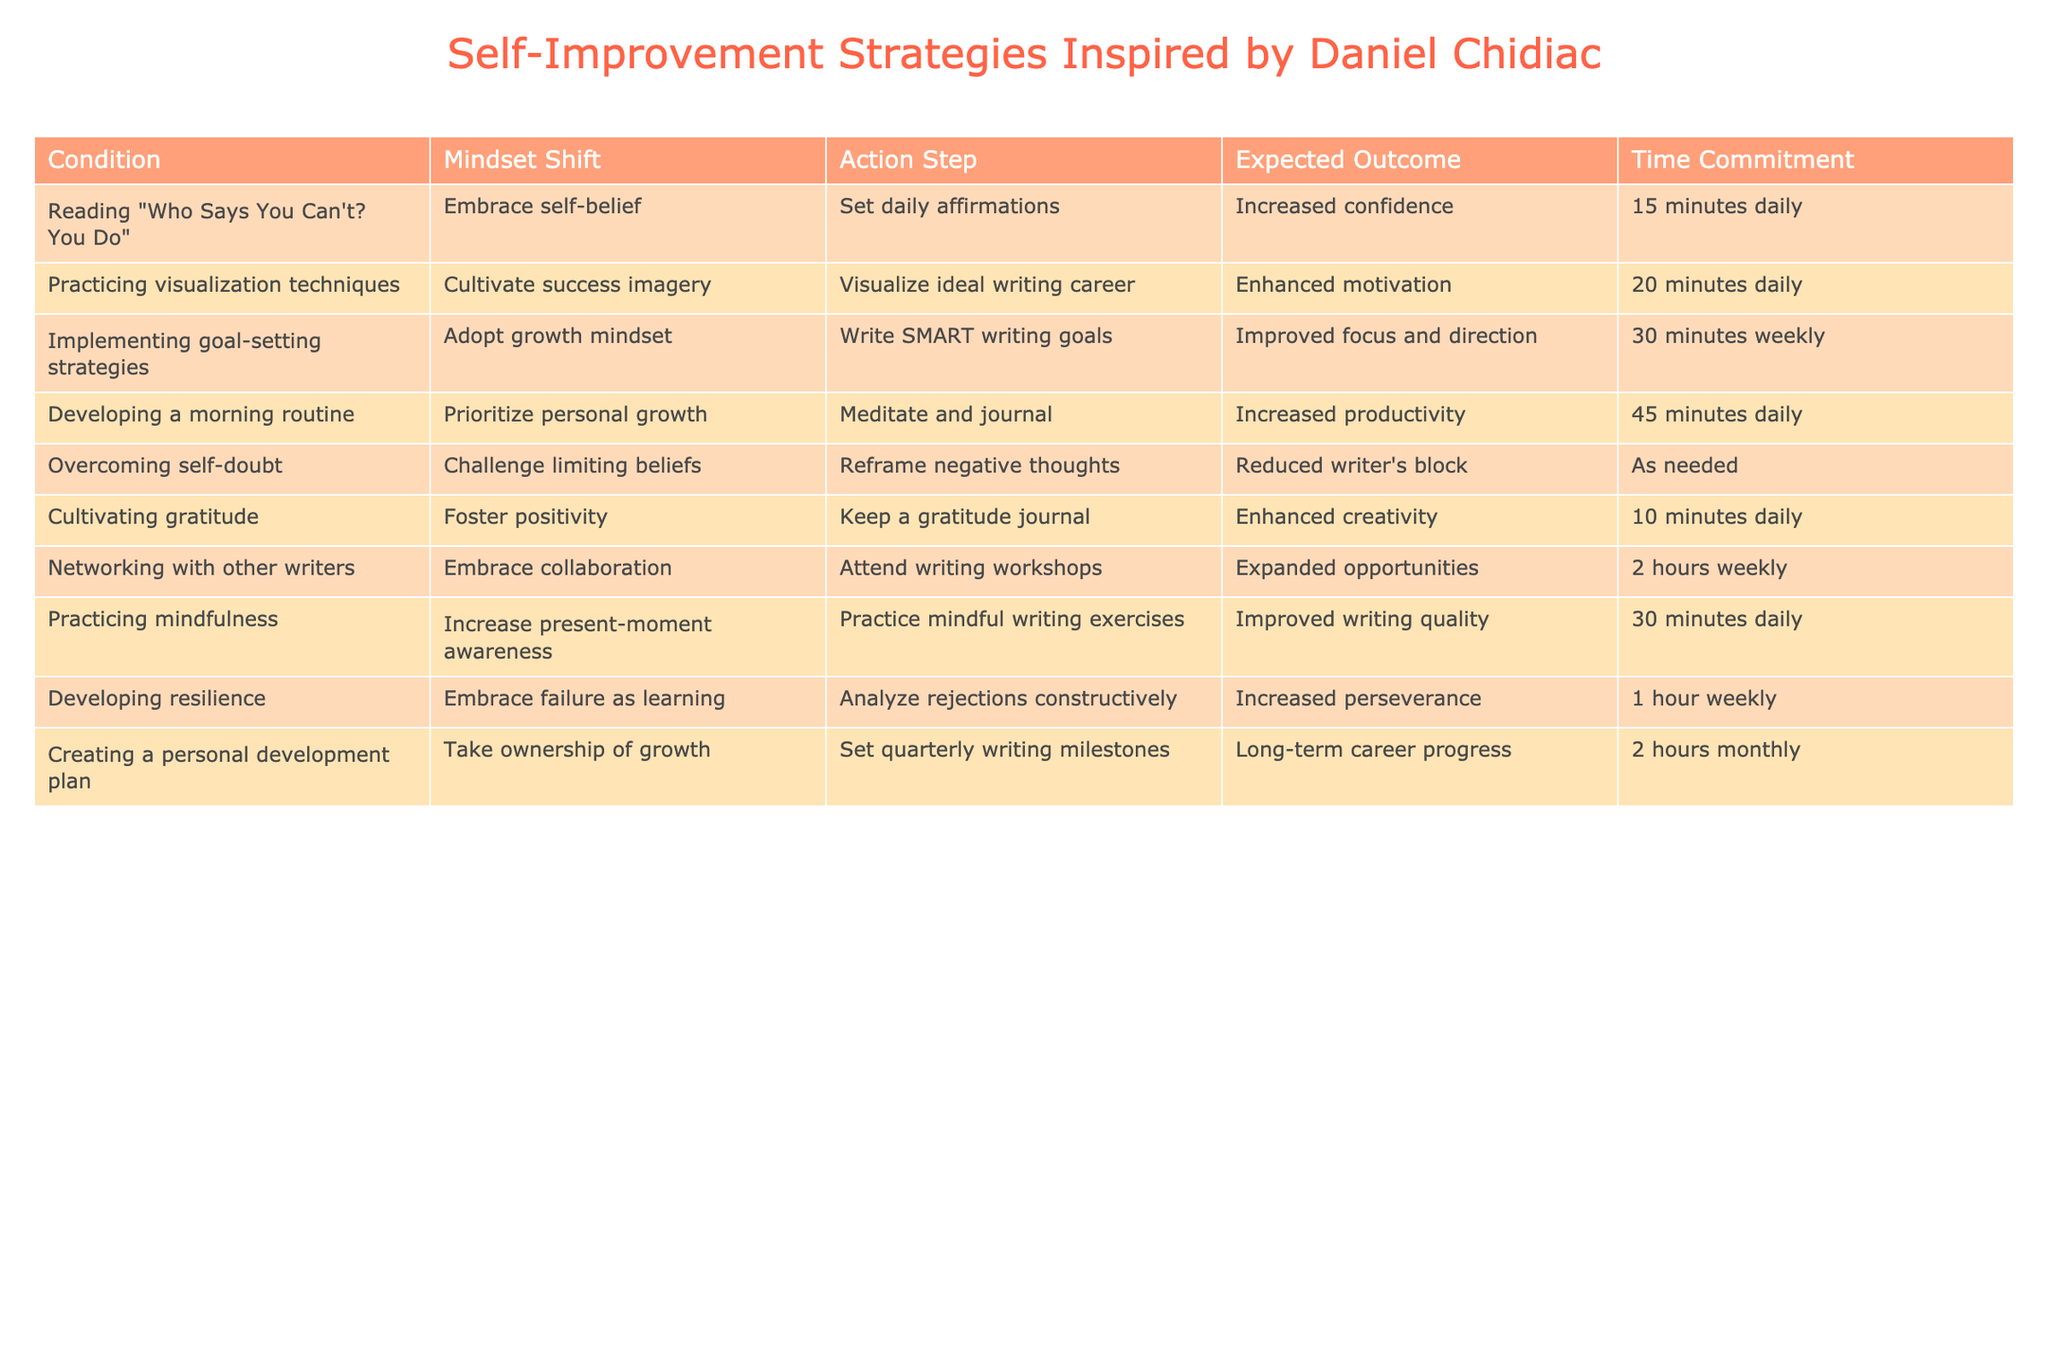What is the expected outcome of practicing visualization techniques? The table shows that practicing visualization techniques, which includes visualizing an ideal writing career, is expected to enhance motivation.
Answer: Enhanced motivation How much time is required daily for cultivating gratitude? The table states that keeping a gratitude journal, which is the action step to cultivate gratitude, requires a commitment of 10 minutes daily.
Answer: 10 minutes daily Which strategy requires the most significant time commitment per week? By examining the time commitments in the table, networking with other writers requires 2 hours weekly, which is the highest compared to other strategies listed.
Answer: Networking with other writers Is there an action step associated with overcoming self-doubt? Yes, according to the table, the action step associated with overcoming self-doubt is to reframe negative thoughts.
Answer: Yes What is the average time commitment for daily self-improvement strategies listed in the table? To find the average time commitment for daily strategies, we sum the daily time commitments (15 + 20 + 45 + 10 + 30 = 120 minutes) and divide by the number of daily strategies (5). This gives us an average of 24 minutes.
Answer: 24 minutes What mindset shift is associated with creating a personal development plan? The table indicates that the mindset shift related to creating a personal development plan is to take ownership of growth.
Answer: Take ownership of growth If someone commits to developing resilience weekly for 1 hour, how does that compare to the time spent on practicing mindfulness daily? Practicing mindfulness takes 30 minutes daily, contributing to a total of 3.5 hours weekly. Since developing resilience takes only 1 hour weekly, mindful practice significantly exceeds it.
Answer: Mindful practice is greater Are daily affirmations linked to improved writing quality? No, the table does not link daily affirmations with improved writing quality; it connects practicing mindfulness with that outcome.
Answer: No Which self-improvement strategy has the shortest expected time commitment? The strategy of cultivating gratitude has the shortest expected time commitment at just 10 minutes daily.
Answer: Cultivating gratitude 